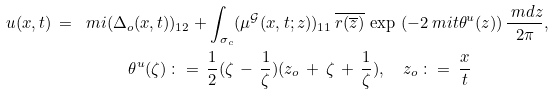Convert formula to latex. <formula><loc_0><loc_0><loc_500><loc_500>u ( x , t ) \, = \, \ m i ( \Delta _ { o } ( x , t ) & ) _ { 1 2 } + \int \nolimits _ { \sigma _ { c } } ( \mu ^ { \mathcal { G } } ( x , t ; z ) ) _ { 1 1 } \, \overline { r ( \overline { z } ) } \, \exp \, \left ( - 2 \ m i t \theta ^ { u } ( z ) \right ) \frac { \ m d z } { 2 \pi } , \\ \theta ^ { u } ( \zeta ) \, & \colon = \, \frac { 1 } { 2 } ( \zeta \, - \, \frac { 1 } { \zeta } ) ( z _ { o } \, + \, \zeta \, + \, \frac { 1 } { \zeta } ) , \quad z _ { o } \, \colon = \, \frac { x } { t }</formula> 